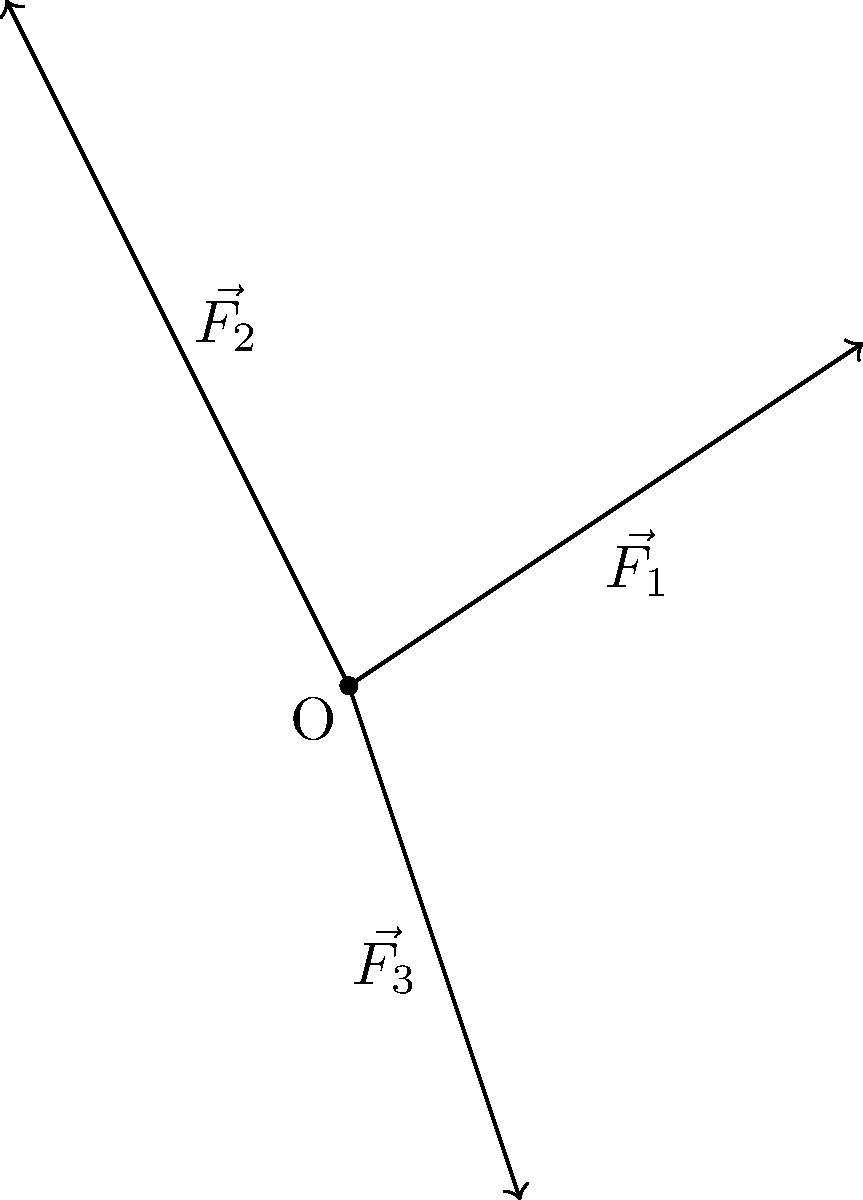In a physics simulation for a game development project, three force vectors $\vec{F_1}$, $\vec{F_2}$, and $\vec{F_3}$ are acting on a point O as shown in the diagram. Given $\vec{F_1} = 3\hat{i} + 2\hat{j}$, $\vec{F_2} = -2\hat{i} + 4\hat{j}$, and $\vec{F_3} = \hat{i} - 3\hat{j}$, calculate the magnitude and direction (in degrees, counterclockwise from the positive x-axis) of the resultant force vector. To solve this problem, we'll follow these steps:

1) First, we need to find the resultant vector by adding all three force vectors:
   $\vec{R} = \vec{F_1} + \vec{F_2} + \vec{F_3}$
   
   $\vec{R} = (3\hat{i} + 2\hat{j}) + (-2\hat{i} + 4\hat{j}) + (\hat{i} - 3\hat{j})$
   
   $\vec{R} = (3-2+1)\hat{i} + (2+4-3)\hat{j} = 2\hat{i} + 3\hat{j}$

2) To find the magnitude of the resultant vector, we use the Pythagorean theorem:
   $|\vec{R}| = \sqrt{2^2 + 3^2} = \sqrt{4 + 9} = \sqrt{13}$

3) To find the direction, we use the arctangent function:
   $\theta = \tan^{-1}(\frac{y}{x}) = \tan^{-1}(\frac{3}{2})$
   
   $\theta = \tan^{-1}(1.5) \approx 56.31°$

Therefore, the magnitude of the resultant force is $\sqrt{13}$ units, and its direction is approximately 56.31° counterclockwise from the positive x-axis.
Answer: Magnitude: $\sqrt{13}$, Direction: 56.31° 